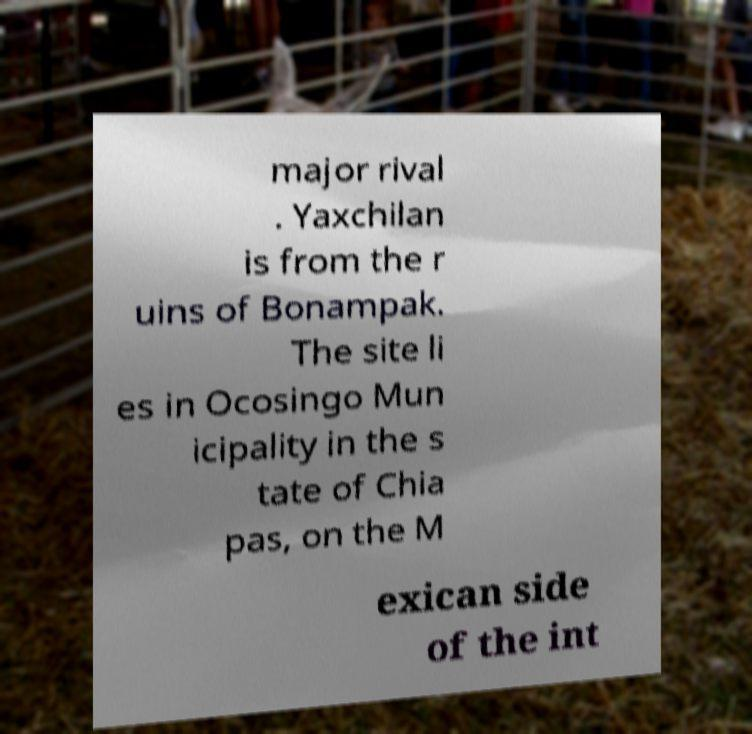I need the written content from this picture converted into text. Can you do that? major rival . Yaxchilan is from the r uins of Bonampak. The site li es in Ocosingo Mun icipality in the s tate of Chia pas, on the M exican side of the int 